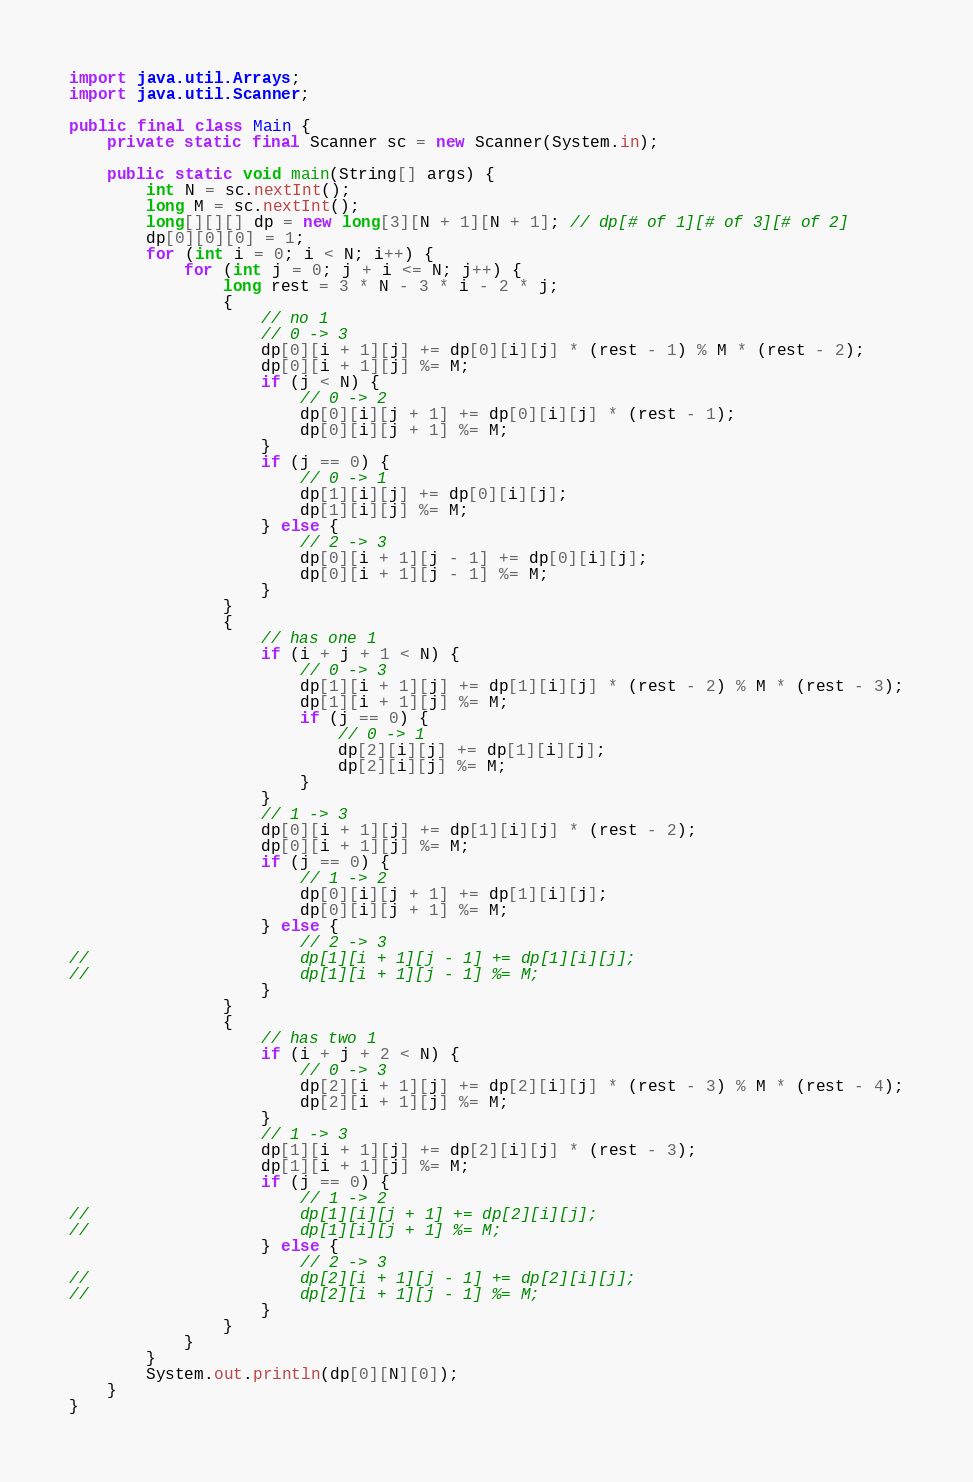<code> <loc_0><loc_0><loc_500><loc_500><_Java_>import java.util.Arrays;
import java.util.Scanner;

public final class Main {
	private static final Scanner sc = new Scanner(System.in);

	public static void main(String[] args) {
		int N = sc.nextInt();
		long M = sc.nextInt();
		long[][][] dp = new long[3][N + 1][N + 1]; // dp[# of 1][# of 3][# of 2]
		dp[0][0][0] = 1;
		for (int i = 0; i < N; i++) {
			for (int j = 0; j + i <= N; j++) {
				long rest = 3 * N - 3 * i - 2 * j;
				{
					// no 1
					// 0 -> 3
					dp[0][i + 1][j] += dp[0][i][j] * (rest - 1) % M * (rest - 2);
					dp[0][i + 1][j] %= M;
					if (j < N) {
						// 0 -> 2
						dp[0][i][j + 1] += dp[0][i][j] * (rest - 1);
						dp[0][i][j + 1] %= M;
					}
					if (j == 0) {
						// 0 -> 1
						dp[1][i][j] += dp[0][i][j];
						dp[1][i][j] %= M;
					} else {
						// 2 -> 3
						dp[0][i + 1][j - 1] += dp[0][i][j];
						dp[0][i + 1][j - 1] %= M;
					}
				}
				{
					// has one 1
					if (i + j + 1 < N) {
						// 0 -> 3
						dp[1][i + 1][j] += dp[1][i][j] * (rest - 2) % M * (rest - 3);
						dp[1][i + 1][j] %= M;
						if (j == 0) {
							// 0 -> 1
							dp[2][i][j] += dp[1][i][j];
							dp[2][i][j] %= M;
						}
					}
					// 1 -> 3
					dp[0][i + 1][j] += dp[1][i][j] * (rest - 2);
					dp[0][i + 1][j] %= M;
					if (j == 0) {
						// 1 -> 2
						dp[0][i][j + 1] += dp[1][i][j];
						dp[0][i][j + 1] %= M;
					} else {
						// 2 -> 3
//						dp[1][i + 1][j - 1] += dp[1][i][j];
//						dp[1][i + 1][j - 1] %= M;
					}
				}
				{
					// has two 1
					if (i + j + 2 < N) {
						// 0 -> 3
						dp[2][i + 1][j] += dp[2][i][j] * (rest - 3) % M * (rest - 4);
						dp[2][i + 1][j] %= M;
					}
					// 1 -> 3
					dp[1][i + 1][j] += dp[2][i][j] * (rest - 3);
					dp[1][i + 1][j] %= M;
					if (j == 0) {
						// 1 -> 2
//						dp[1][i][j + 1] += dp[2][i][j];
//						dp[1][i][j + 1] %= M;
					} else {
						// 2 -> 3
//						dp[2][i + 1][j - 1] += dp[2][i][j];
//						dp[2][i + 1][j - 1] %= M;
					}
				}
			}
		}
		System.out.println(dp[0][N][0]);
	}
}
</code> 